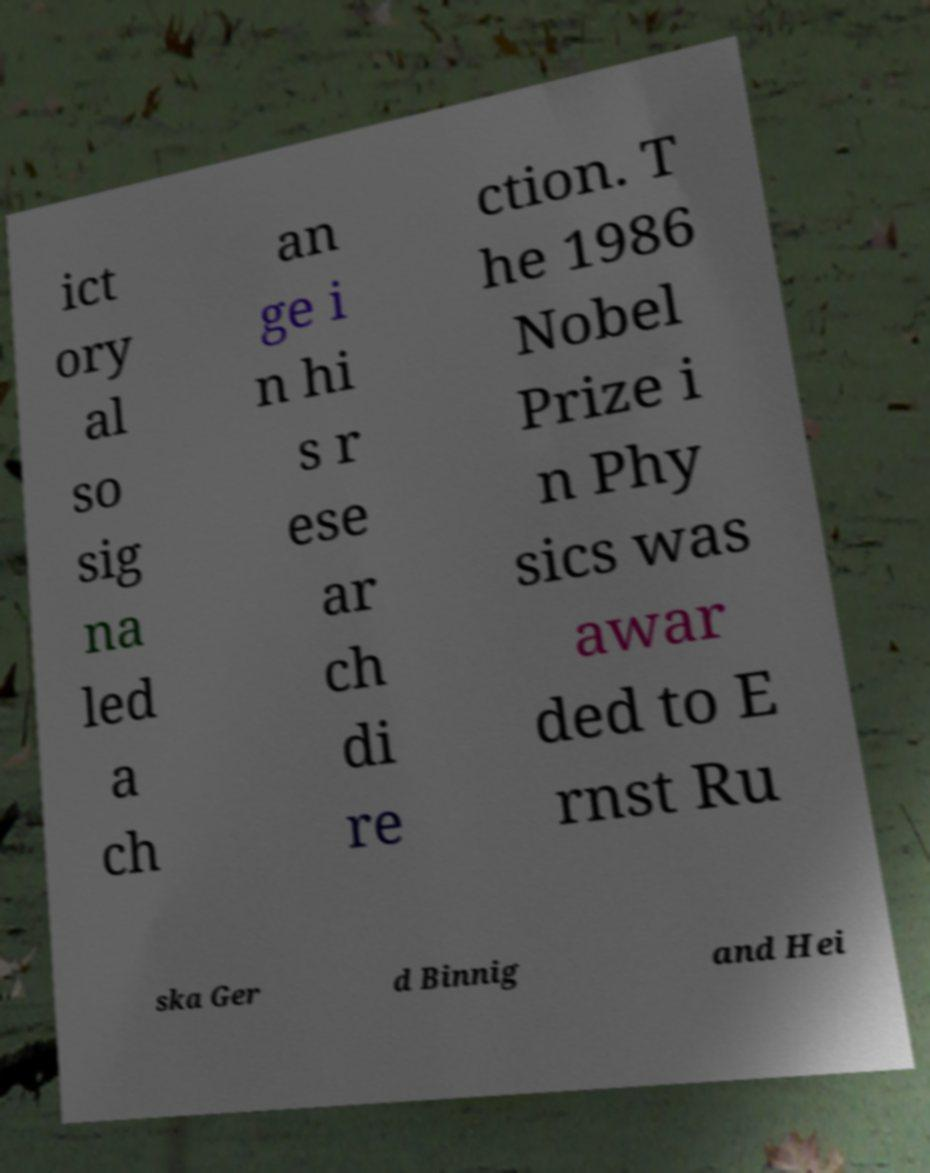I need the written content from this picture converted into text. Can you do that? ict ory al so sig na led a ch an ge i n hi s r ese ar ch di re ction. T he 1986 Nobel Prize i n Phy sics was awar ded to E rnst Ru ska Ger d Binnig and Hei 